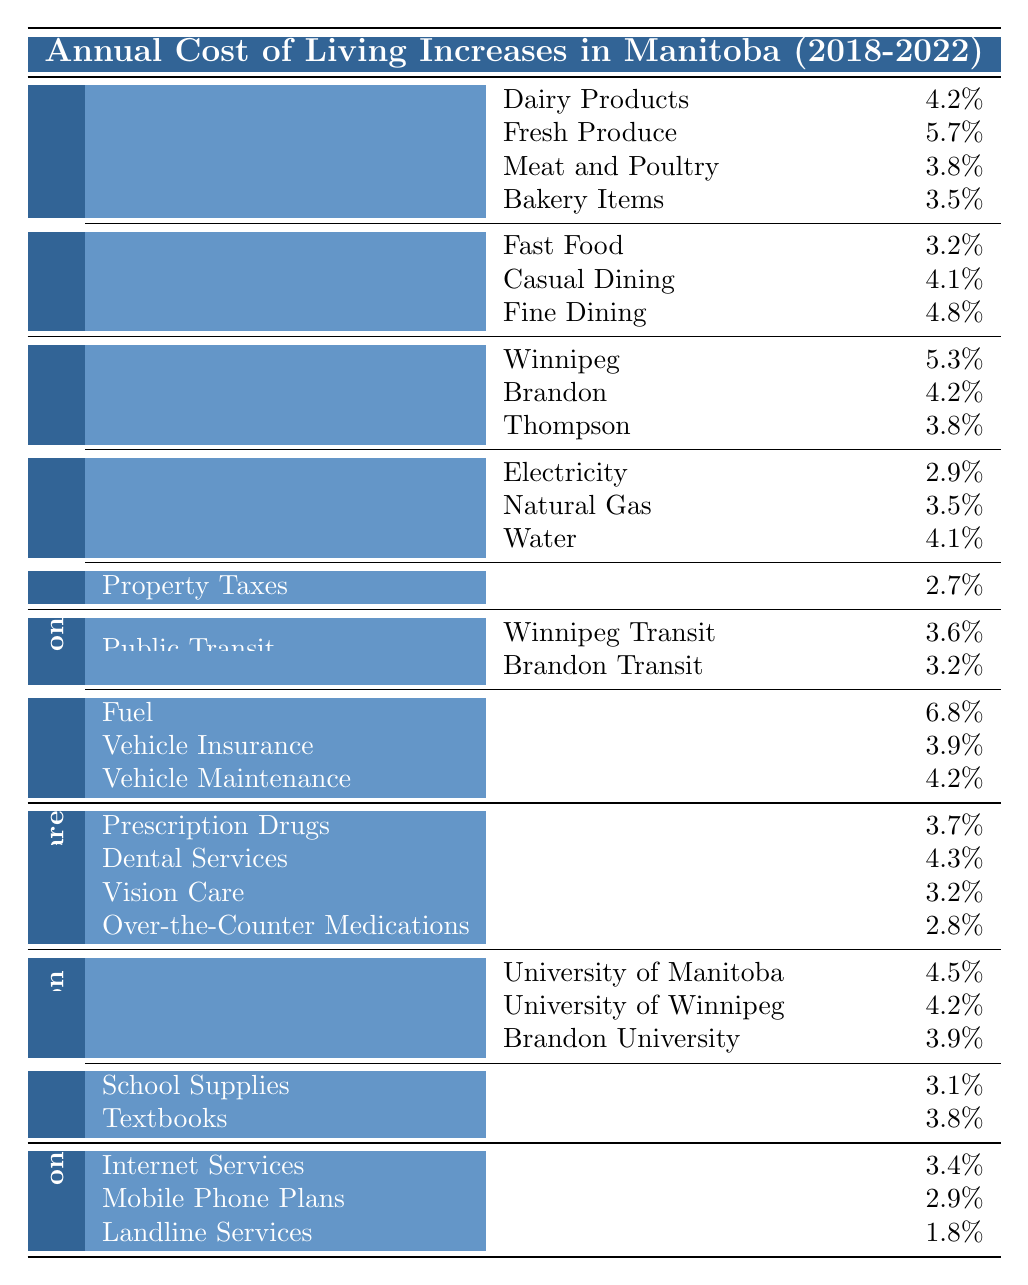What is the percentage increase for dairy products? The table indicates that the annual cost of living increase for dairy products is 4.2%.
Answer: 4.2% Which category of food experienced the highest increase? From the table, fresh produce had the highest increase at 5.7% among groceries.
Answer: Fresh Produce (5.7%) What is the total percentage increase for utilities combined? The increases for utilities are 2.9% (Electricity) + 3.5% (Natural Gas) + 4.1% (Water) = 10.5%.
Answer: 10.5% Did the vehicle insurance increase more than public transit in Winnipeg? The vehicle insurance increased by 3.9%, which is greater than the 3.6% increase for Winnipeg Transit.
Answer: Yes What is the average increase for university tuition across the three universities listed? The increases are 4.5% (University of Manitoba), 4.2% (University of Winnipeg), and 3.9% (Brandon University). The average is (4.5 + 4.2 + 3.9) / 3 = 4.2%.
Answer: 4.2% Is the increase in fuel costs higher than the increase in meat and poultry? Fuel costs increased by 6.8%, while meat and poultry had a 3.8% increase. Thus, fuel costs increased more.
Answer: Yes What is the difference between the highest and lowest increase in the communication category? The highest increase in communication is 3.4% (Internet Services) and the lowest is 1.8% (Landline Services), so the difference is 3.4% - 1.8% = 1.6%.
Answer: 1.6% Which category has the lowest overall percentage increase for essential goods and services? By reviewing the table, the communication category has the lowest increase values with the highest being 3.4% and the lowest being 1.8%. The average is lower than other categories.
Answer: Communication How much did the rent increase in Winnipeg compared to Thompson? The rent in Winnipeg increased by 5.3% and in Thompson by 3.8%. The difference is 5.3% - 3.8% = 1.5%.
Answer: 1.5% What is the overall percentage increase for healthcare services? The healthcare increases are 3.7% (Prescription Drugs), 4.3% (Dental Services), 3.2% (Vision Care), and 2.8% (Over-the-Counter Medications). The total increase is (3.7 + 4.3 + 3.2 + 2.8) = 14%. To find the average, we divide by 4: 14% / 4 = 3.5%.
Answer: 3.5% Which essential service had the highest annual cost of living increase in 2022? Reviewing the table, fuel had the highest increase at 6.8%, which is the most significant overall.
Answer: Fuel (6.8%) 